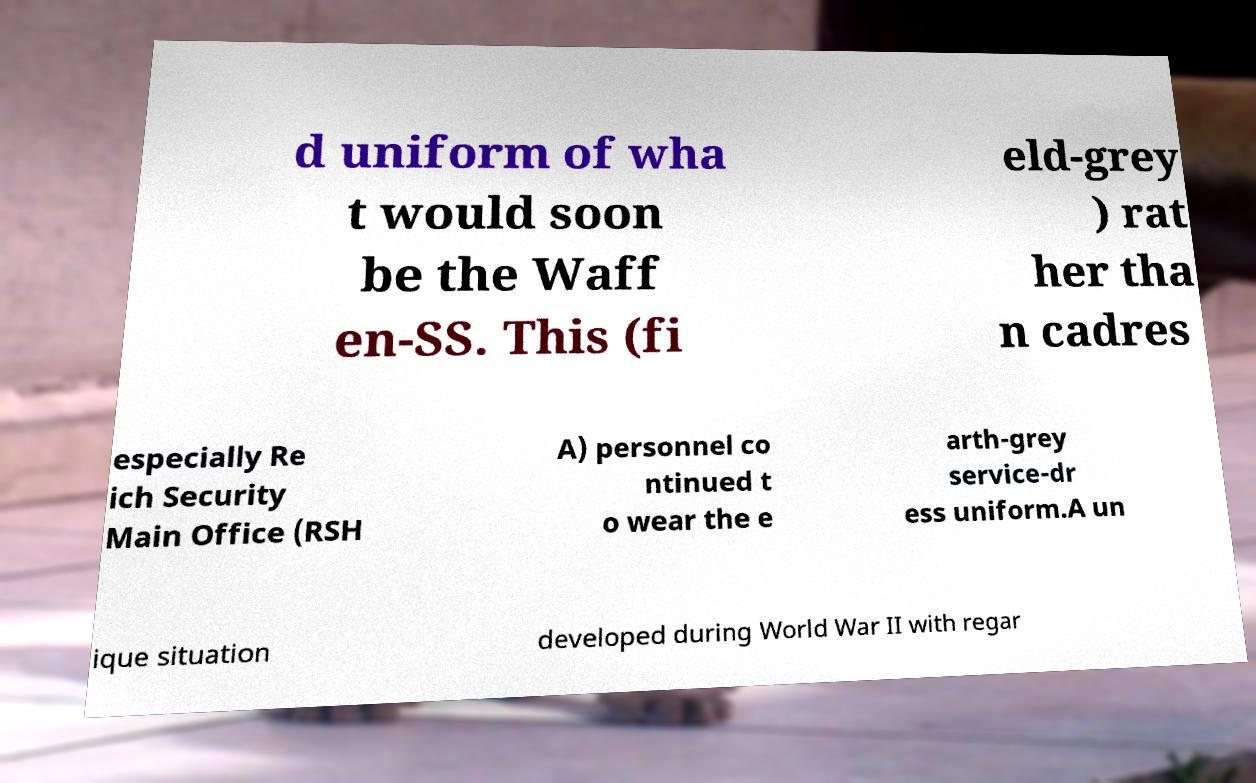For documentation purposes, I need the text within this image transcribed. Could you provide that? d uniform of wha t would soon be the Waff en-SS. This (fi eld-grey ) rat her tha n cadres especially Re ich Security Main Office (RSH A) personnel co ntinued t o wear the e arth-grey service-dr ess uniform.A un ique situation developed during World War II with regar 